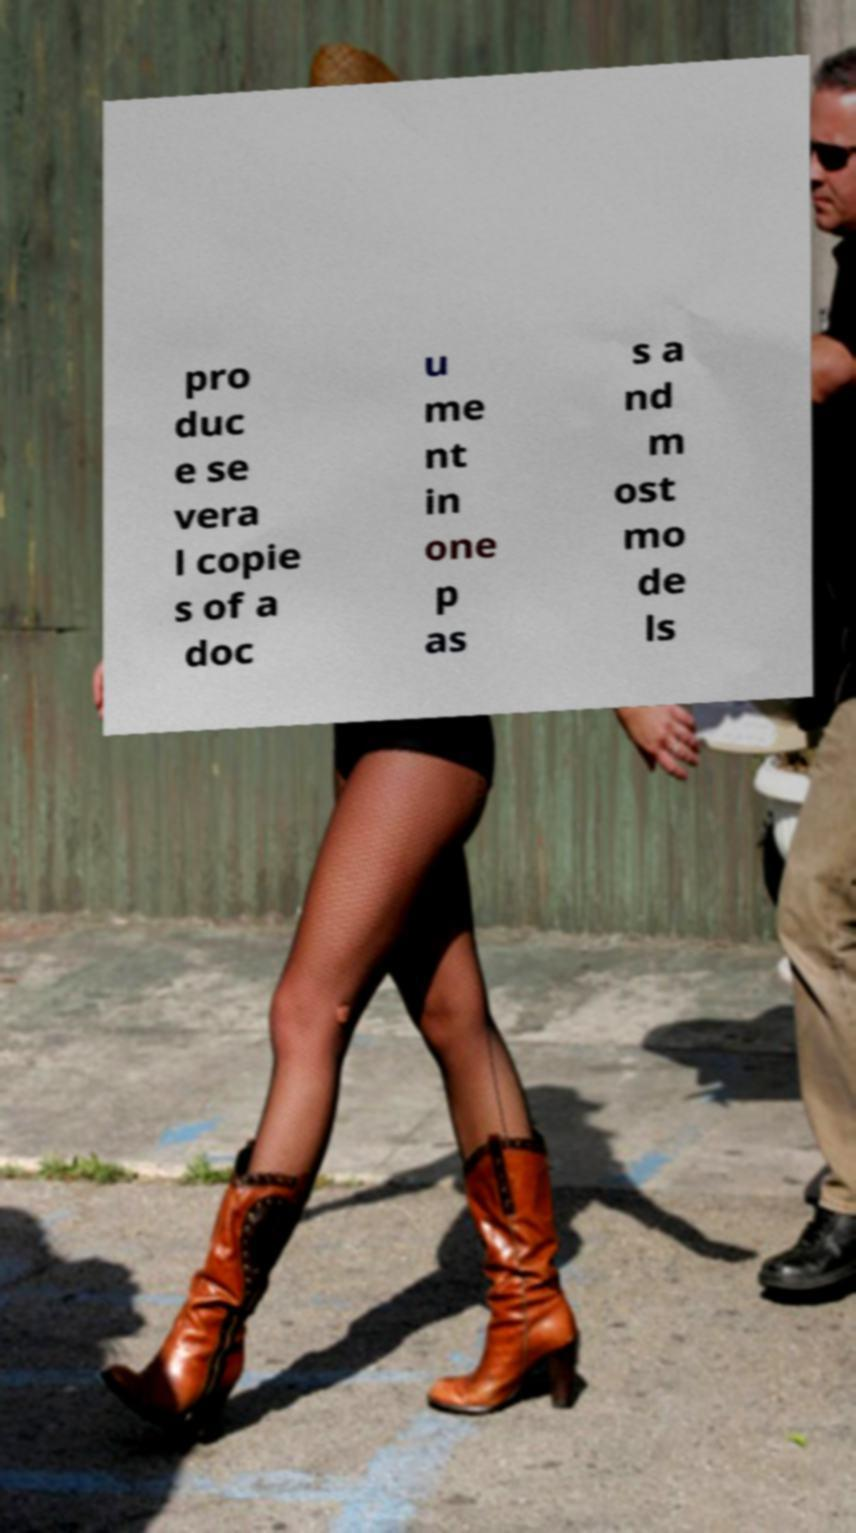For documentation purposes, I need the text within this image transcribed. Could you provide that? pro duc e se vera l copie s of a doc u me nt in one p as s a nd m ost mo de ls 